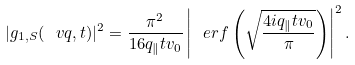Convert formula to latex. <formula><loc_0><loc_0><loc_500><loc_500>| g _ { 1 , S } ( \ v q , t ) | ^ { 2 } = \frac { \pi ^ { 2 } } { 1 6 q _ { \| } t v _ { 0 } } \left | \ e r f \left ( \sqrt { \frac { 4 i q _ { \| } t v _ { 0 } } { \pi } } \right ) \right | ^ { 2 } .</formula> 